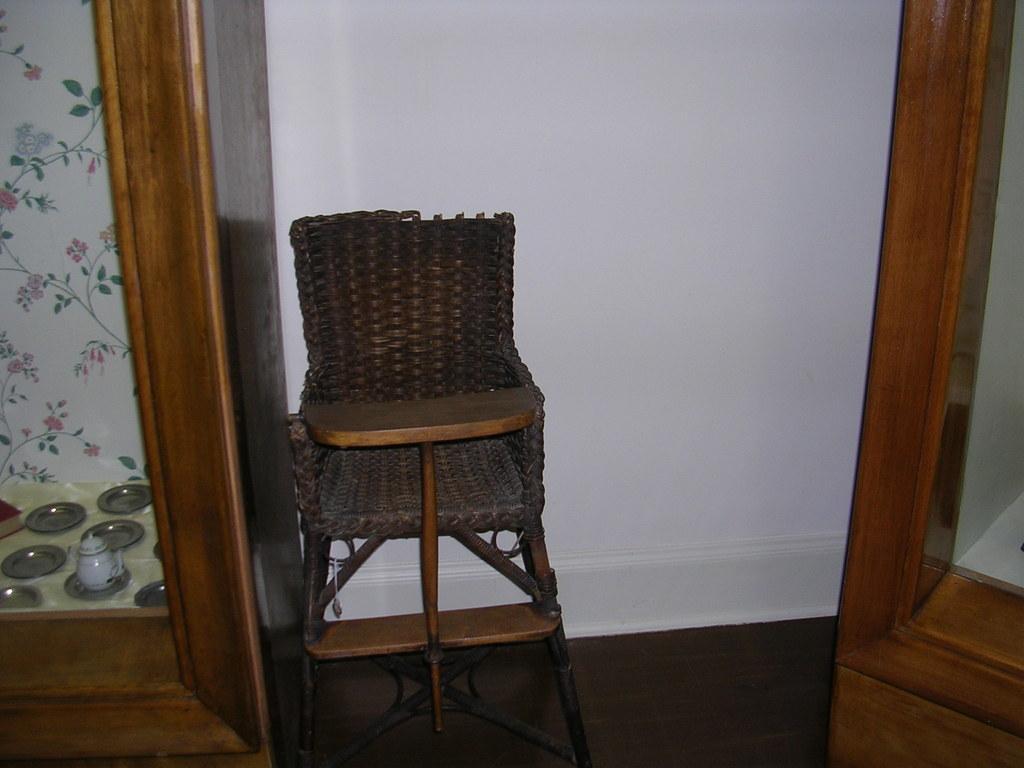Could you give a brief overview of what you see in this image? In the center of the image, we can see a chair an din the background, there are cupboards and we can see some utensils and there is a wall. At the bottom, there is floor. 